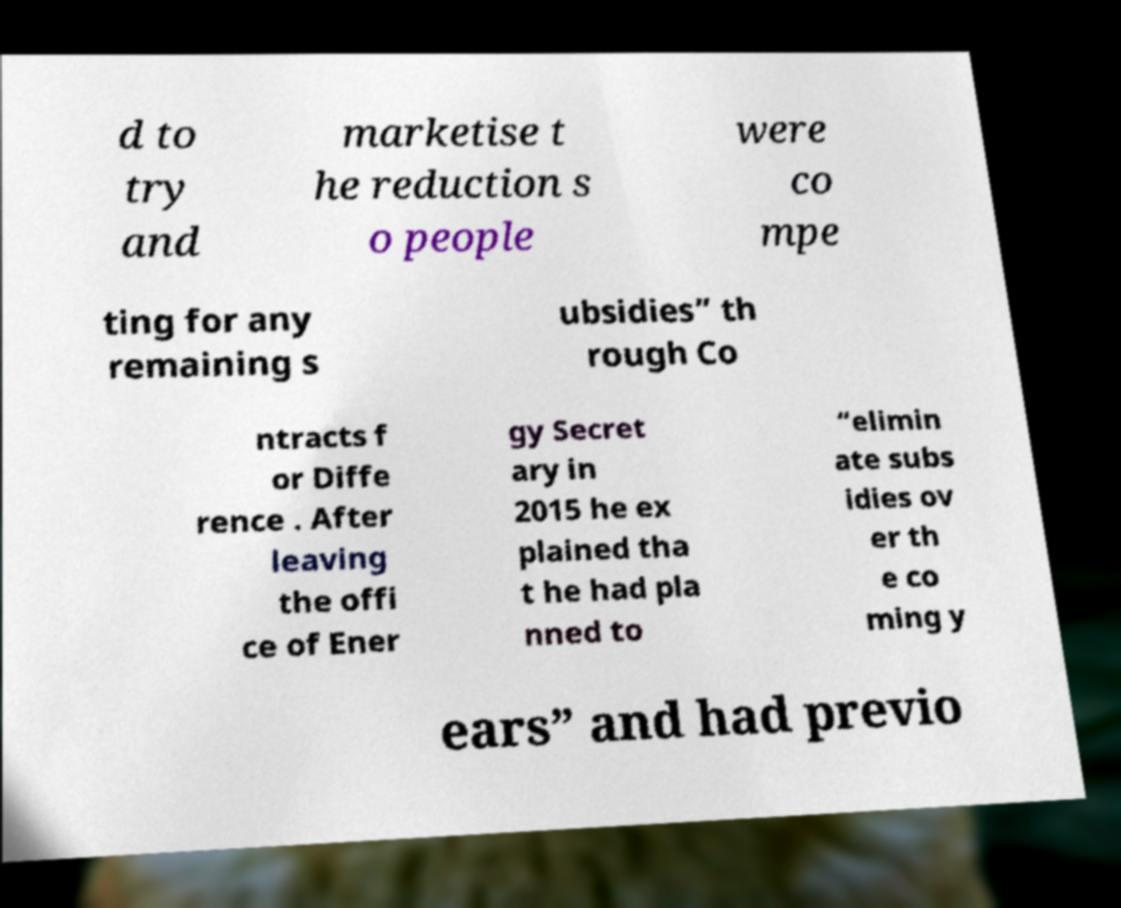Please identify and transcribe the text found in this image. d to try and marketise t he reduction s o people were co mpe ting for any remaining s ubsidies” th rough Co ntracts f or Diffe rence . After leaving the offi ce of Ener gy Secret ary in 2015 he ex plained tha t he had pla nned to “elimin ate subs idies ov er th e co ming y ears” and had previo 